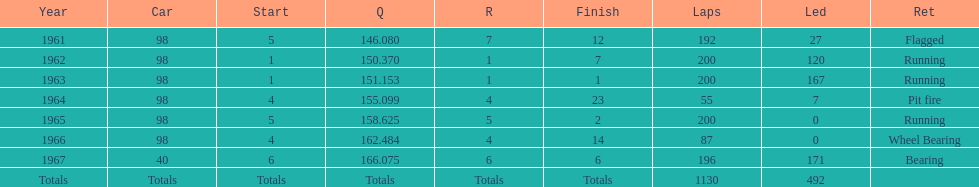Previous to 1965, when did jones have a number 5 start at the indy 500? 1961. 